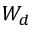Convert formula to latex. <formula><loc_0><loc_0><loc_500><loc_500>W _ { d }</formula> 